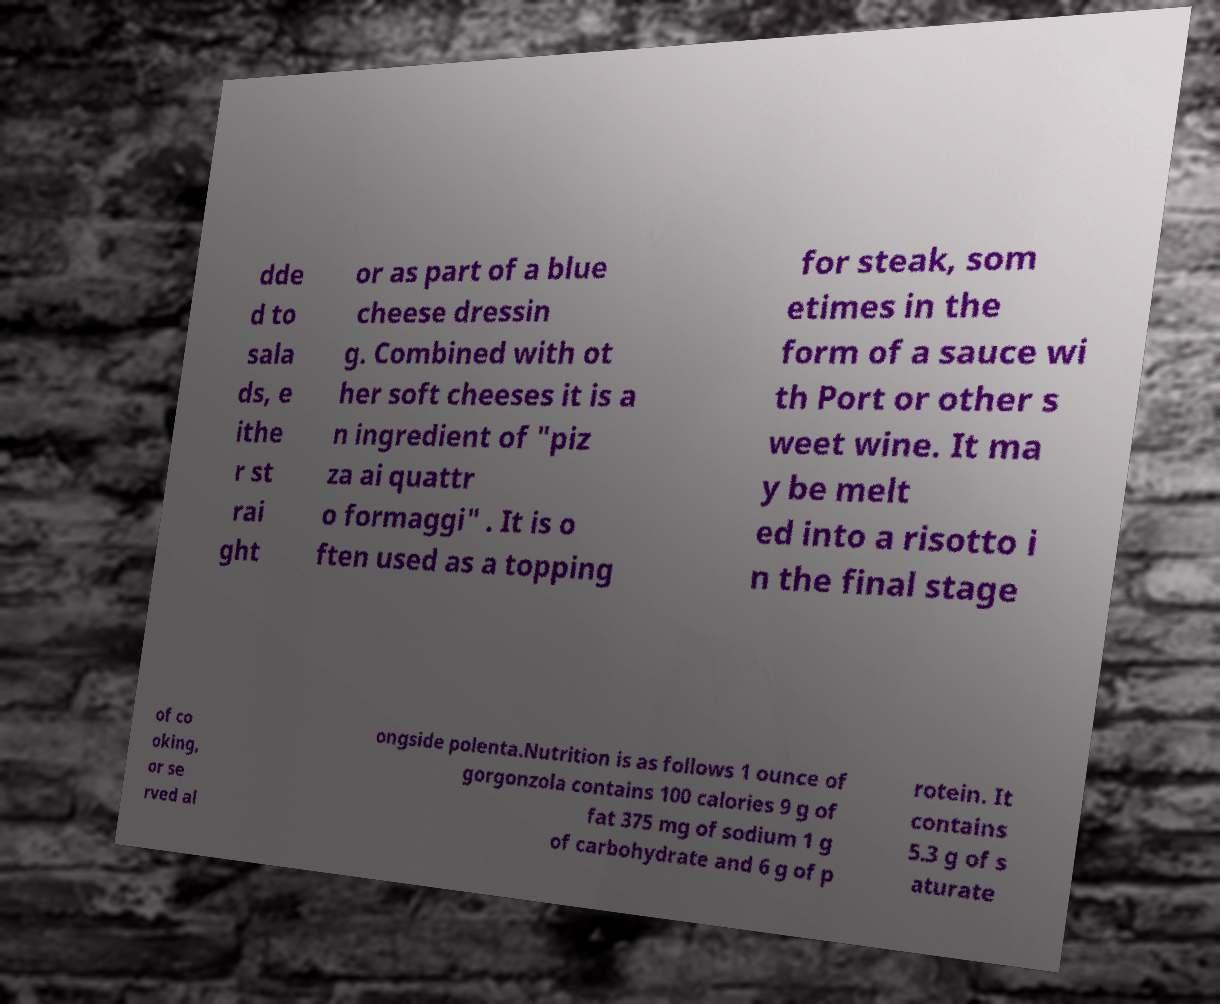For documentation purposes, I need the text within this image transcribed. Could you provide that? Of course! Here's the complete transcription from the image:

"Added to salads, either straight or as part of a blue cheese dressing. Combined with other soft cheeses it is an ingredient of 'pizza ai quattro formaggi'. It is often used as a topping for steak, sometimes in the form of a sauce with Port or other sweet wine. It may be melted into a risotto in the final stage of cooking, or served alongside polenta.

Nutrition is as follows: 1 ounce of gorgonzola contains 100 calories, 9 g of fat, 375 mg of sodium, 1 g of carbohydrate, and 6 g of protein. It contains 5.3 g of saturated fat." 